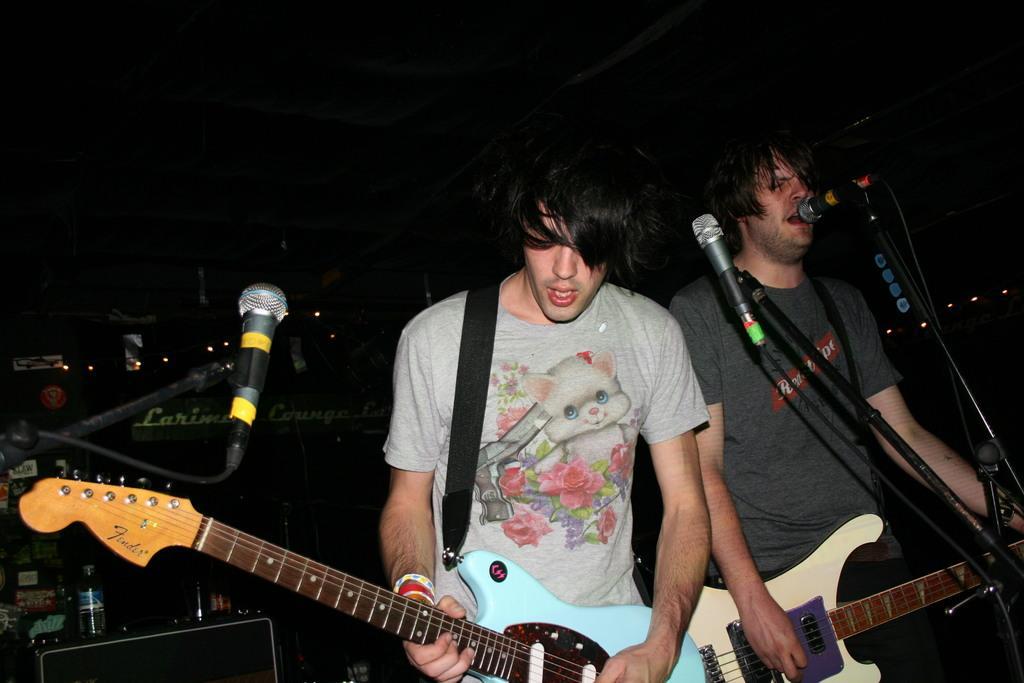Could you give a brief overview of what you see in this image? There are two men in this picture, holding a guitars in their hands and playing them. Both of them are having microphones and stands in front of them. They are singing. 